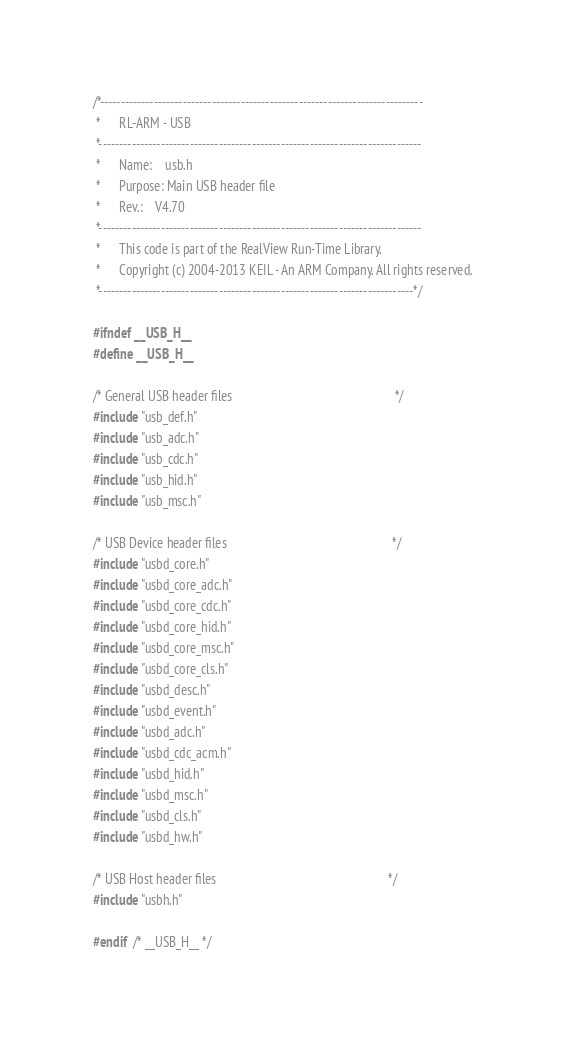<code> <loc_0><loc_0><loc_500><loc_500><_C_>/*------------------------------------------------------------------------------
 *      RL-ARM - USB
 *------------------------------------------------------------------------------
 *      Name:    usb.h
 *      Purpose: Main USB header file
 *      Rev.:    V4.70
 *------------------------------------------------------------------------------
 *      This code is part of the RealView Run-Time Library.
 *      Copyright (c) 2004-2013 KEIL - An ARM Company. All rights reserved.
 *----------------------------------------------------------------------------*/

#ifndef __USB_H__
#define __USB_H__

/* General USB header files                                                   */
#include "usb_def.h"
#include "usb_adc.h"
#include "usb_cdc.h"
#include "usb_hid.h"
#include "usb_msc.h"

/* USB Device header files                                                    */
#include "usbd_core.h"
#include "usbd_core_adc.h"
#include "usbd_core_cdc.h"
#include "usbd_core_hid.h"
#include "usbd_core_msc.h"
#include "usbd_core_cls.h"
#include "usbd_desc.h"
#include "usbd_event.h"
#include "usbd_adc.h"
#include "usbd_cdc_acm.h"
#include "usbd_hid.h"
#include "usbd_msc.h"
#include "usbd_cls.h"
#include "usbd_hw.h"

/* USB Host header files                                                      */
#include "usbh.h"

#endif  /* __USB_H__ */
</code> 